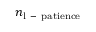<formula> <loc_0><loc_0><loc_500><loc_500>n _ { l \mathrm { - } p a t i e n c e }</formula> 